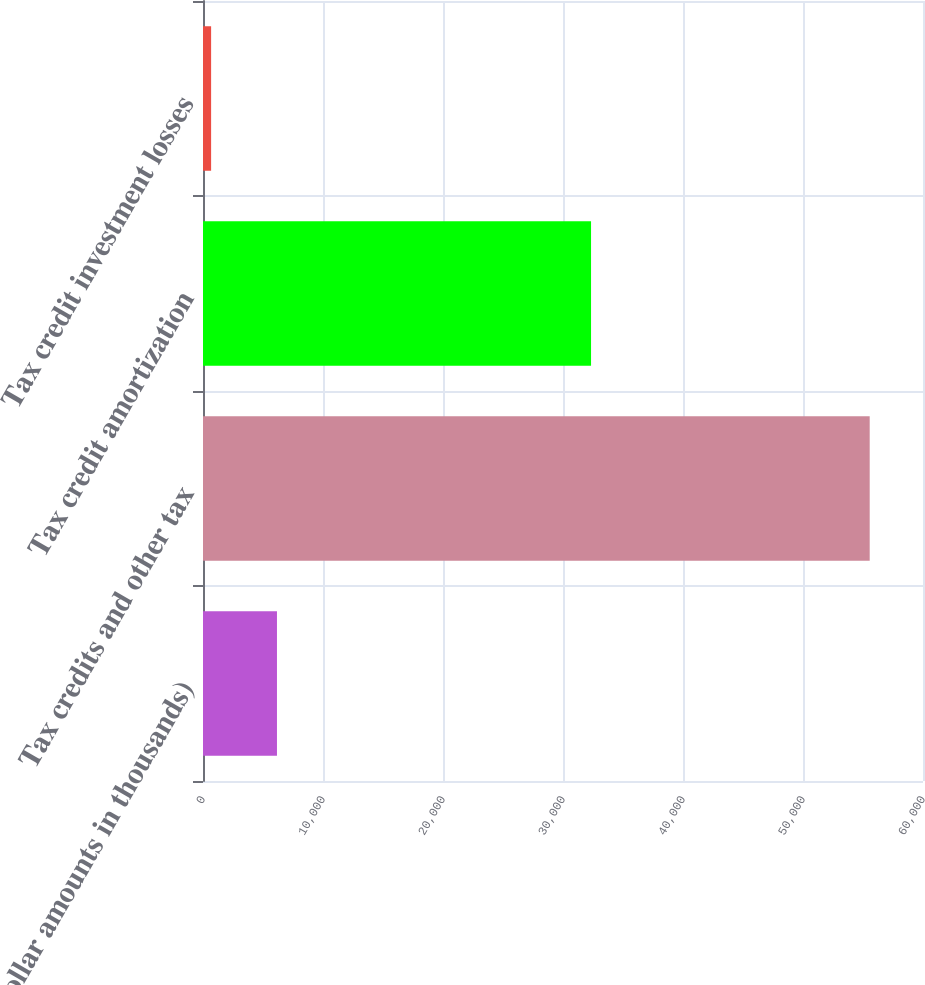Convert chart. <chart><loc_0><loc_0><loc_500><loc_500><bar_chart><fcel>(dollar amounts in thousands)<fcel>Tax credits and other tax<fcel>Tax credit amortization<fcel>Tax credit investment losses<nl><fcel>6164.2<fcel>55558<fcel>32337<fcel>676<nl></chart> 